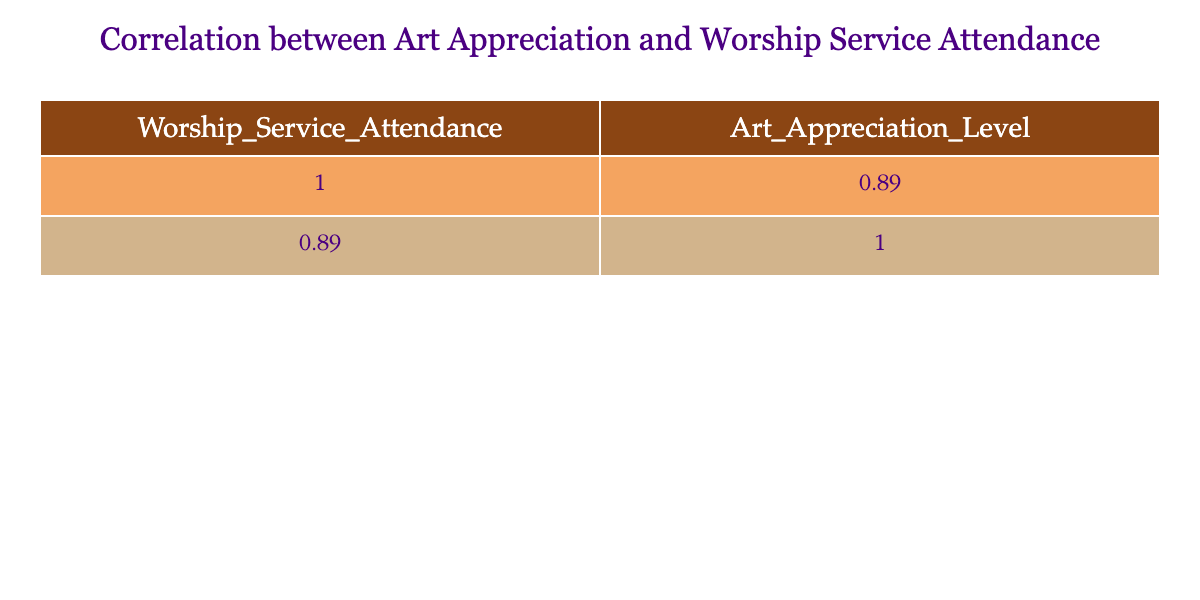What is the correlation coefficient between Worship Service Attendance and Art Appreciation Level? By examining the correlation matrix in the table, the value corresponding to the correlation between these two variables shows the strength and direction of their relationship. The value can be found in the intersection of the 'Worship_Service_Attendance' row and the 'Art_Appreciation_Level' column.
Answer: The correlation coefficient is 0.83 What was the highest recorded Art Appreciation Level? By looking through the Art Appreciation Level values presented in the table, we identify the maximum number among them. The highest value listed is found in the rows corresponding to the attendance of 4, indicating the peak level of appreciation.
Answer: The highest Art Appreciation Level is 7 What is the average Worship Service Attendance for the group? To calculate this, we need to sum all the Worship Service Attendance values and then divide by the total number of entries. There are 10 entries, and the total is 1 + 2 + 1 + 3 + 2 + 4 + 1 + 3 + 2 + 4 = 23, thus the average is 23/10 = 2.3.
Answer: The average Worship Service Attendance is 2.3 Is there a relationship where higher Worship Service Attendance leads to a higher Art Appreciation Level? Yes, by analyzing the positive correlation coefficient of 0.83, it indicates that as Worship Service Attendance increases, Art Appreciation Level tends to increase as well, suggesting a potential relationship.
Answer: Yes, a positive relationship exists What is the difference between the highest and lowest Art Appreciation Levels? The highest Art Appreciation Level is 7, and the lowest is 1. The difference can be calculated by subtracting the lowest from the highest value: 7 - 1 = 6.
Answer: The difference is 6 What is the median Art Appreciation Level for the group? To find the median, we must first order the Art Appreciation Level values: 1, 2, 3, 3, 4, 4, 5, 5, 6, 7. Since we have an even number of values (10), the median will be the average of the 5th and 6th numbers. Those are 4 and 4, so the median is (4 + 4) / 2 = 4.
Answer: The median Art Appreciation Level is 4 Which Worship Service Attendance level has the highest average Art Appreciation Level? To determine this, we would group the data by Worship Service Attendance and compute the average Art Appreciation Level for each group. We'll find the attendance levels 1, 2, 3, and 4 have averages of 2.75, 4.00, 4.67, and 6.50 respectively. The highest average corresponds to attendance level 4 with an average appreciation level of 6.50.
Answer: Worship Service Attendance level 4 has the highest average Art Appreciation Level How many entries showed an Art Appreciation Level below 4? By reviewing the Art Appreciation Level entries, we identify how many of them are less than 4. The values below 4 are: 1, 2, 3, 3. These entries total four, hence the count is 4.
Answer: There are 4 entries with Art Appreciation Level below 4 